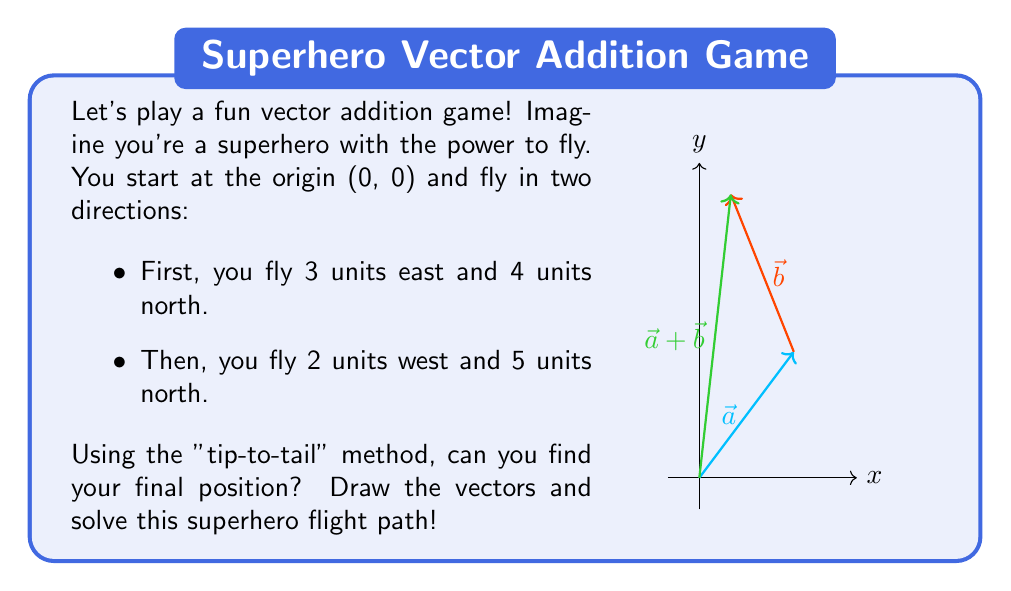Show me your answer to this math problem. Let's solve this step-by-step using the "tip-to-tail" method:

1) First, let's define our vectors:
   $\vec{a} = (3, 4)$ (3 units east, 4 units north)
   $\vec{b} = (-2, 5)$ (2 units west, 5 units north)

2) In the "tip-to-tail" method, we place the tail of the second vector at the tip of the first vector.

3) To add these vectors, we can simply add their components:

   $\vec{a} + \vec{b} = (a_x + b_x, a_y + b_y)$

4) Let's calculate:
   $x$ component: $3 + (-2) = 1$
   $y$ component: $4 + 5 = 9$

5) Therefore, $\vec{a} + \vec{b} = (1, 9)$

This means our superhero's final position is 1 unit east and 9 units north from the starting point.

The green arrow in the diagram represents this final position vector.
Answer: $(1, 9)$ 